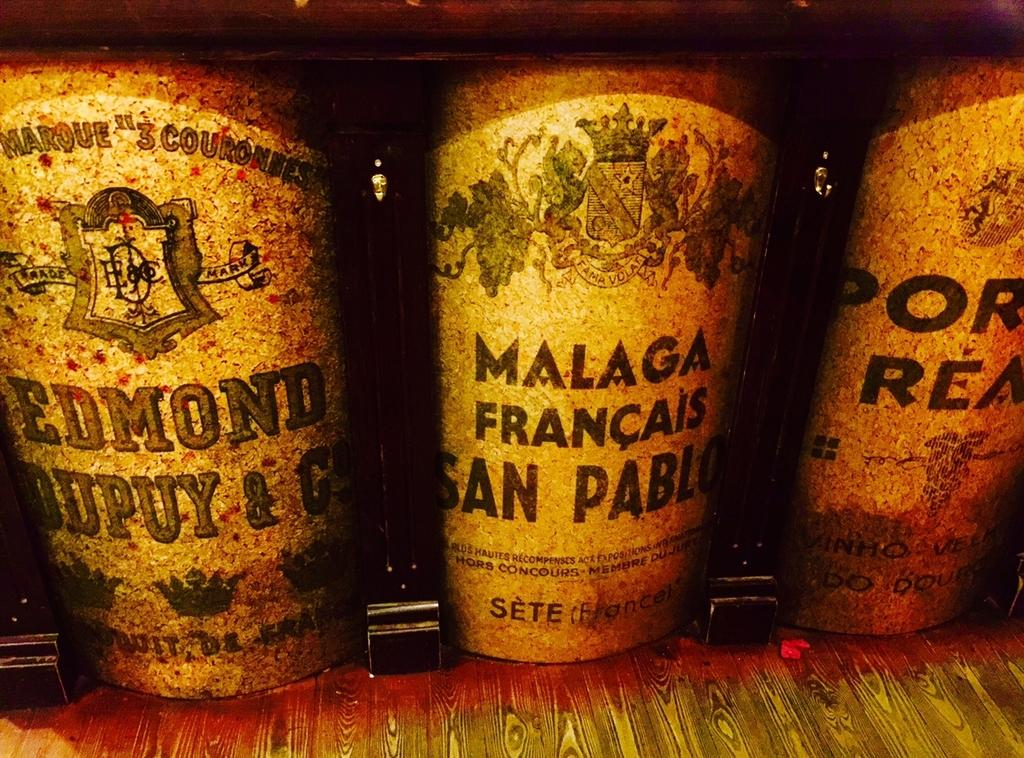<image>
Render a clear and concise summary of the photo. several old bottles lined up reading Malaga Francais San Pablo 